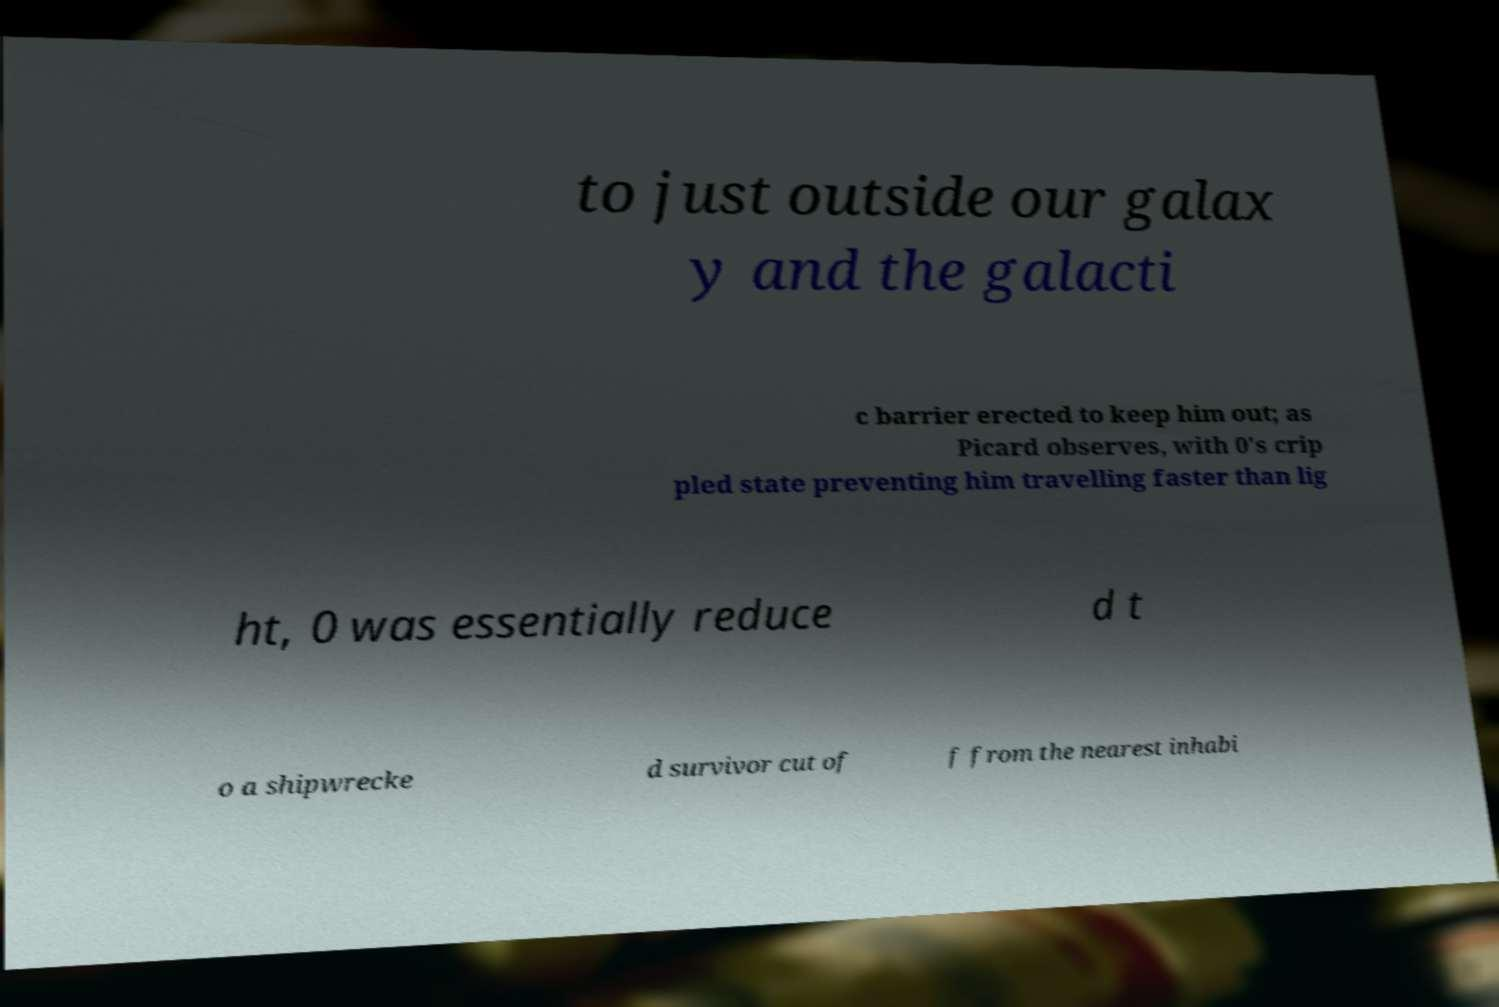Can you accurately transcribe the text from the provided image for me? to just outside our galax y and the galacti c barrier erected to keep him out; as Picard observes, with 0's crip pled state preventing him travelling faster than lig ht, 0 was essentially reduce d t o a shipwrecke d survivor cut of f from the nearest inhabi 